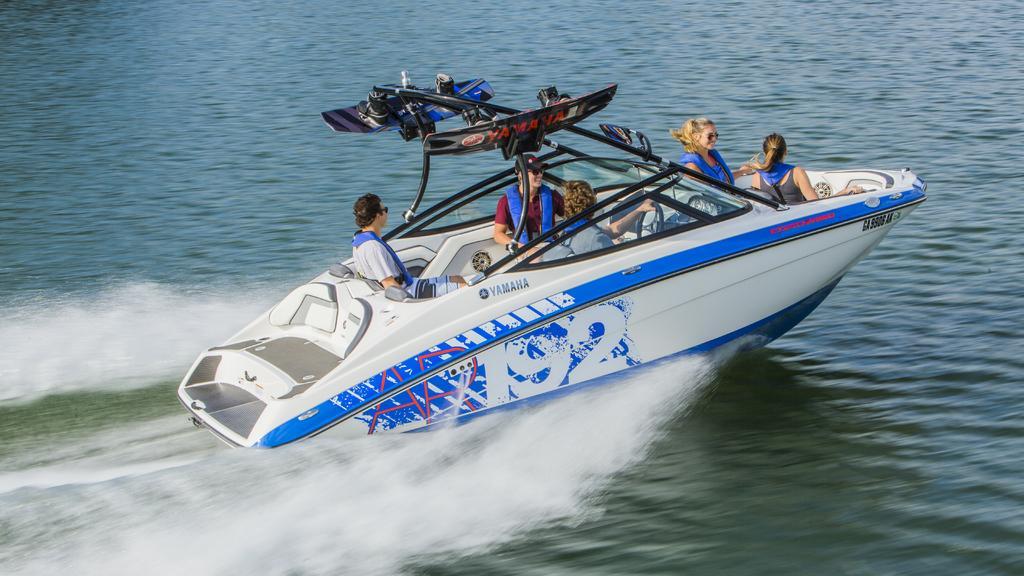Could you give a brief overview of what you see in this image? In the picture I can see people are sitting on a boat. The boat is white in color and is on the water. 